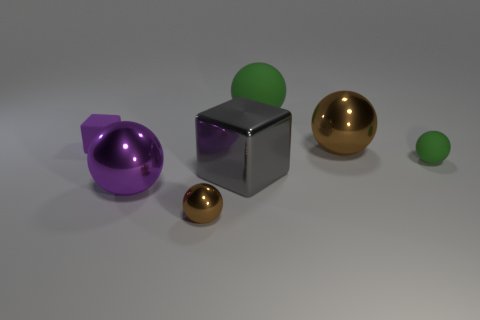There is a large matte object that is the same shape as the purple shiny object; what is its color?
Give a very brief answer. Green. Are there the same number of brown shiny balls behind the small rubber cube and purple metal things?
Offer a very short reply. No. There is a thing that is the same color as the small rubber block; what shape is it?
Your answer should be very brief. Sphere. How many brown spheres are the same size as the shiny cube?
Provide a succinct answer. 1. What number of tiny rubber things are left of the large brown shiny thing?
Give a very brief answer. 1. What material is the large green object that is behind the small rubber thing on the left side of the big purple ball?
Offer a very short reply. Rubber. Are there any matte cubes of the same color as the metallic block?
Provide a short and direct response. No. What size is the purple sphere that is made of the same material as the tiny brown thing?
Your answer should be very brief. Large. Are there any other things that have the same color as the small metallic sphere?
Offer a terse response. Yes. What is the color of the large object that is behind the purple matte object?
Keep it short and to the point. Green. 